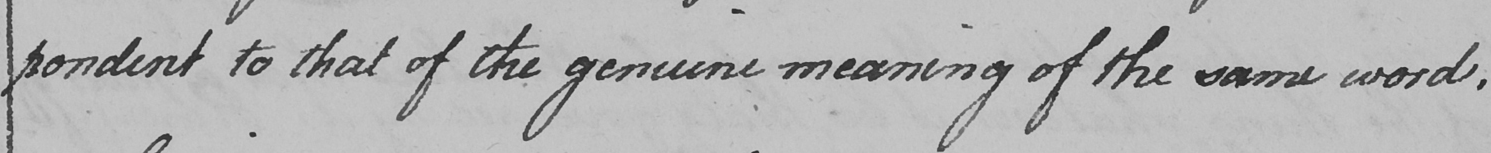What is written in this line of handwriting? -pondent to that of the genuine meaning of the same word . 